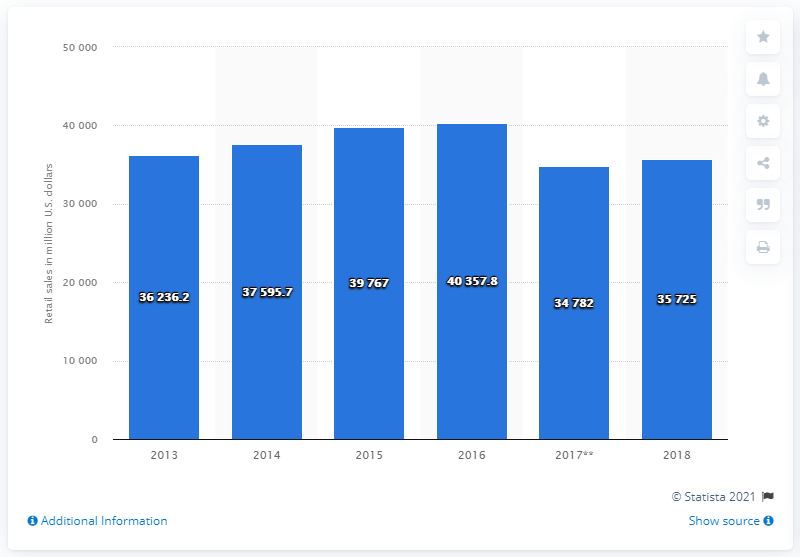Outline some significant characteristics in this image. The previous year's revenue for the U.S. vision care market was approximately 39,767. In 2016, the U.S. vision care market generated approximately 40,357.8 units of currency. 